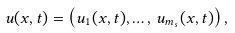Convert formula to latex. <formula><loc_0><loc_0><loc_500><loc_500>u ( x , t ) = \left ( u _ { 1 } ( x , t ) , \dots , \, u _ { m _ { s } } ( x , t ) \right ) ,</formula> 